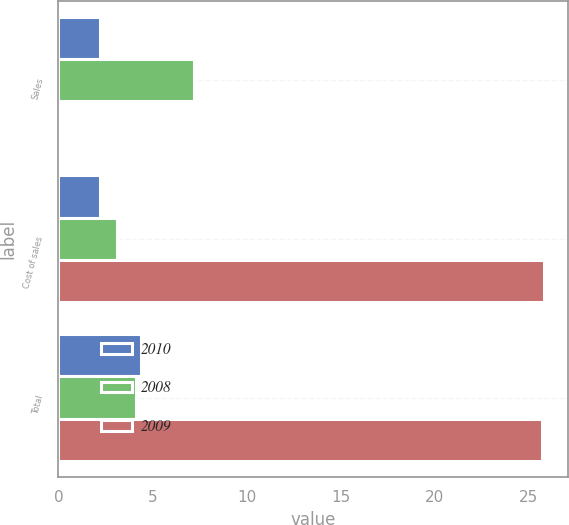<chart> <loc_0><loc_0><loc_500><loc_500><stacked_bar_chart><ecel><fcel>Sales<fcel>Cost of sales<fcel>Total<nl><fcel>2010<fcel>2.2<fcel>2.2<fcel>4.4<nl><fcel>2008<fcel>7.2<fcel>3.1<fcel>4.1<nl><fcel>2009<fcel>0.1<fcel>25.8<fcel>25.7<nl></chart> 